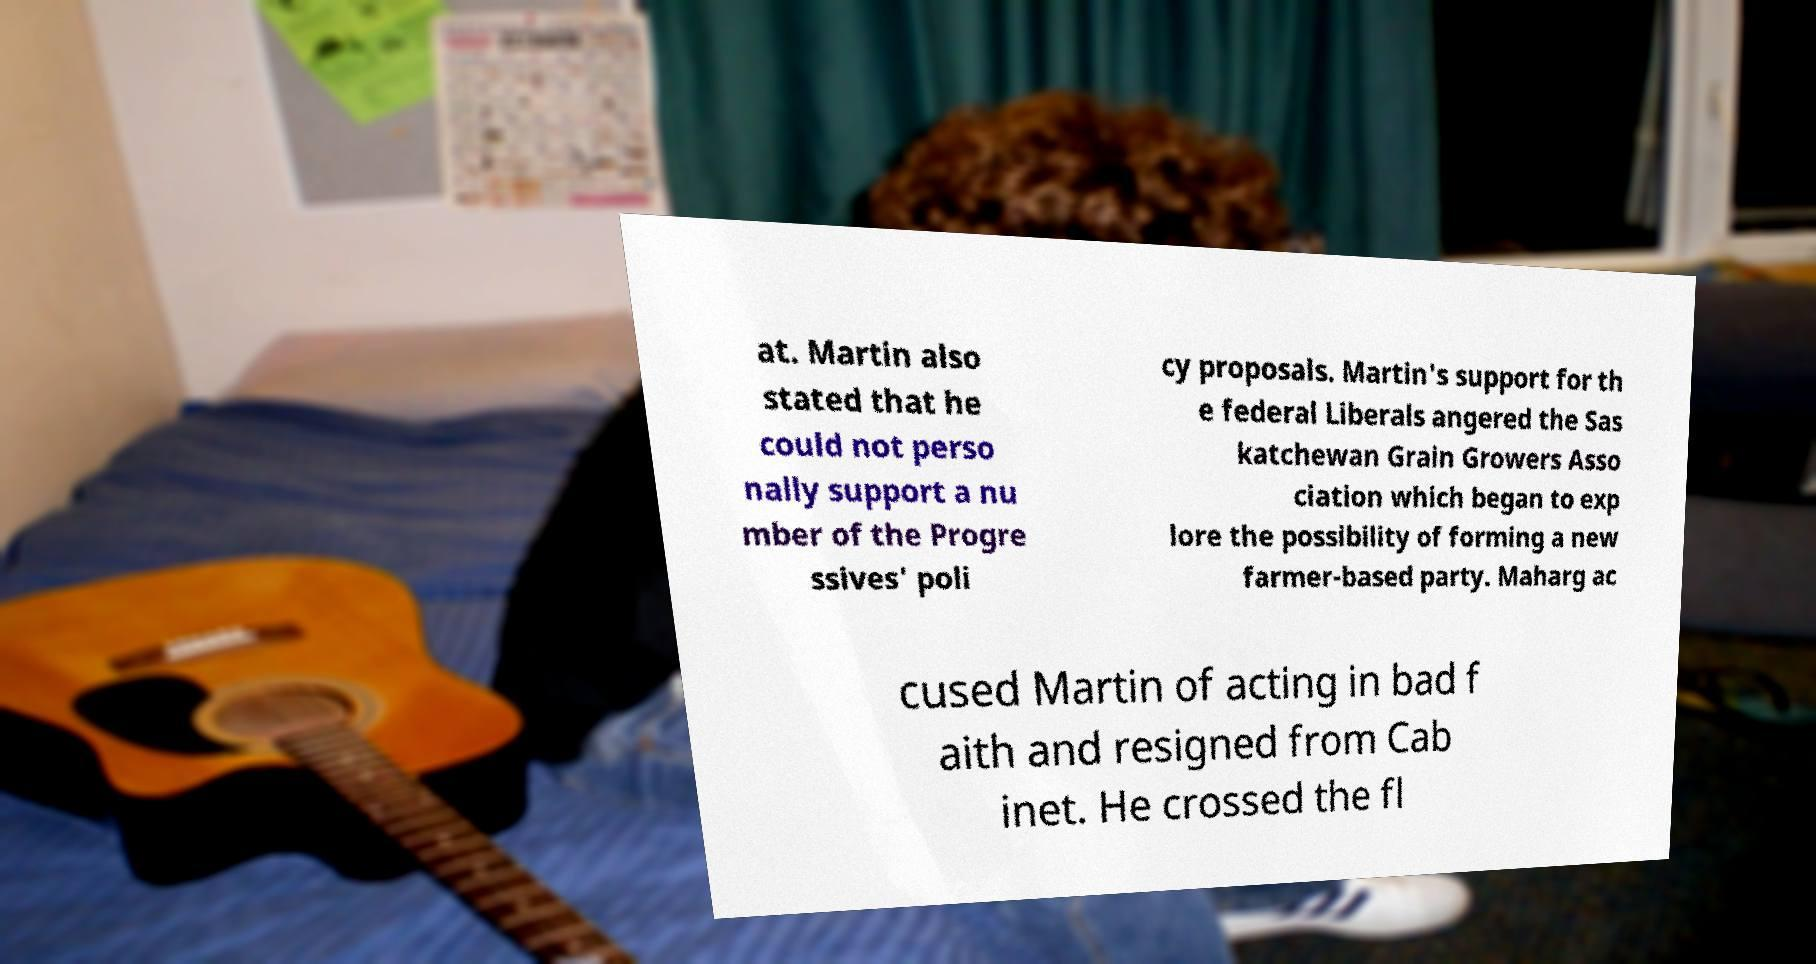Please identify and transcribe the text found in this image. at. Martin also stated that he could not perso nally support a nu mber of the Progre ssives' poli cy proposals. Martin's support for th e federal Liberals angered the Sas katchewan Grain Growers Asso ciation which began to exp lore the possibility of forming a new farmer-based party. Maharg ac cused Martin of acting in bad f aith and resigned from Cab inet. He crossed the fl 